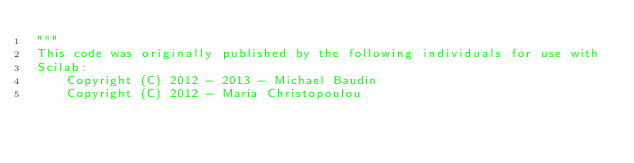<code> <loc_0><loc_0><loc_500><loc_500><_Python_>"""
This code was originally published by the following individuals for use with
Scilab:
    Copyright (C) 2012 - 2013 - Michael Baudin
    Copyright (C) 2012 - Maria Christopoulou</code> 